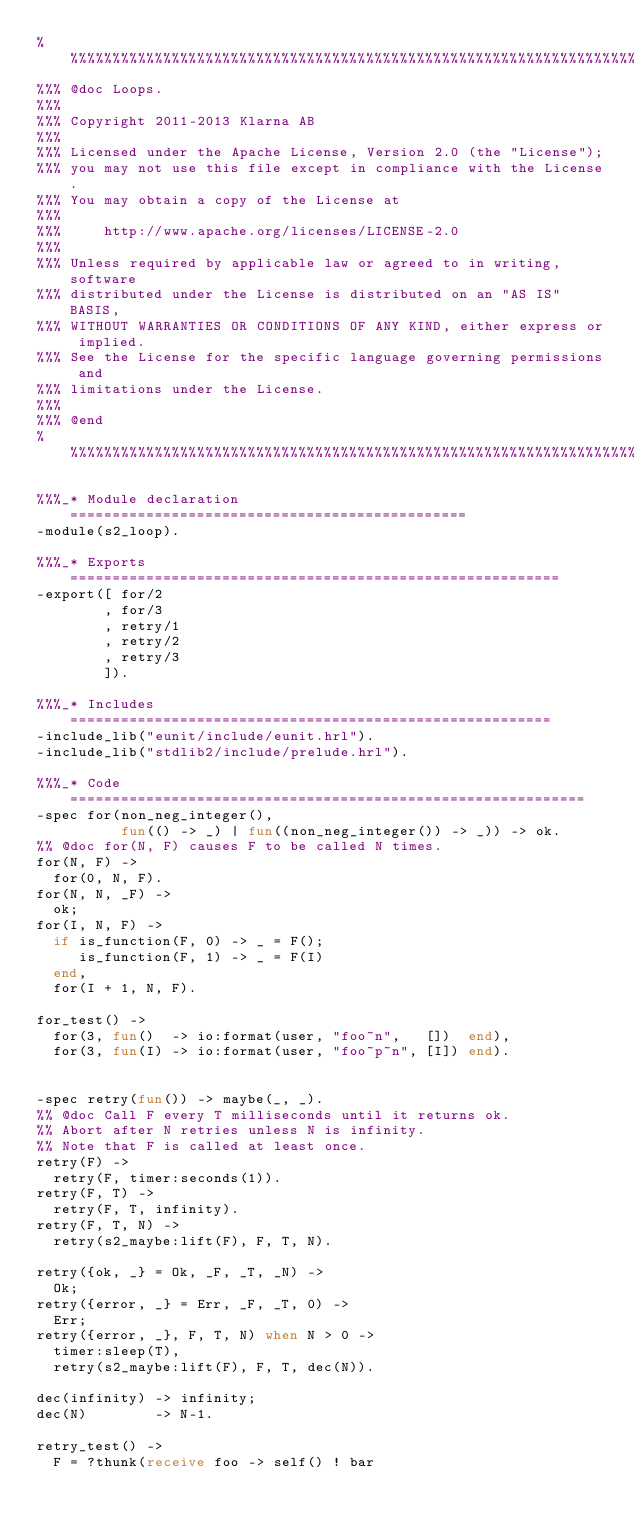<code> <loc_0><loc_0><loc_500><loc_500><_Erlang_>%%%%%%%%%%%%%%%%%%%%%%%%%%%%%%%%%%%%%%%%%%%%%%%%%%%%%%%%%%%%%%%%%%%%%%%%%%%%%%%
%%% @doc Loops.
%%%
%%% Copyright 2011-2013 Klarna AB
%%%
%%% Licensed under the Apache License, Version 2.0 (the "License");
%%% you may not use this file except in compliance with the License.
%%% You may obtain a copy of the License at
%%%
%%%     http://www.apache.org/licenses/LICENSE-2.0
%%%
%%% Unless required by applicable law or agreed to in writing, software
%%% distributed under the License is distributed on an "AS IS" BASIS,
%%% WITHOUT WARRANTIES OR CONDITIONS OF ANY KIND, either express or implied.
%%% See the License for the specific language governing permissions and
%%% limitations under the License.
%%%
%%% @end
%%%%%%%%%%%%%%%%%%%%%%%%%%%%%%%%%%%%%%%%%%%%%%%%%%%%%%%%%%%%%%%%%%%%%%%%%%%%%%%

%%%_* Module declaration ===============================================
-module(s2_loop).

%%%_* Exports ==========================================================
-export([ for/2
        , for/3
        , retry/1
        , retry/2
        , retry/3
        ]).

%%%_* Includes =========================================================
-include_lib("eunit/include/eunit.hrl").
-include_lib("stdlib2/include/prelude.hrl").

%%%_* Code =============================================================
-spec for(non_neg_integer(),
          fun(() -> _) | fun((non_neg_integer()) -> _)) -> ok.
%% @doc for(N, F) causes F to be called N times.
for(N, F) ->
  for(0, N, F).
for(N, N, _F) ->
  ok;
for(I, N, F) ->
  if is_function(F, 0) -> _ = F();
     is_function(F, 1) -> _ = F(I)
  end,
  for(I + 1, N, F).

for_test() ->
  for(3, fun()  -> io:format(user, "foo~n",   [])  end),
  for(3, fun(I) -> io:format(user, "foo~p~n", [I]) end).


-spec retry(fun()) -> maybe(_, _).
%% @doc Call F every T milliseconds until it returns ok.
%% Abort after N retries unless N is infinity.
%% Note that F is called at least once.
retry(F) ->
  retry(F, timer:seconds(1)).
retry(F, T) ->
  retry(F, T, infinity).
retry(F, T, N) ->
  retry(s2_maybe:lift(F), F, T, N).

retry({ok, _} = Ok, _F, _T, _N) ->
  Ok;
retry({error, _} = Err, _F, _T, 0) ->
  Err;
retry({error, _}, F, T, N) when N > 0 ->
  timer:sleep(T),
  retry(s2_maybe:lift(F), F, T, dec(N)).

dec(infinity) -> infinity;
dec(N)        -> N-1.

retry_test() ->
  F = ?thunk(receive foo -> self() ! bar</code> 